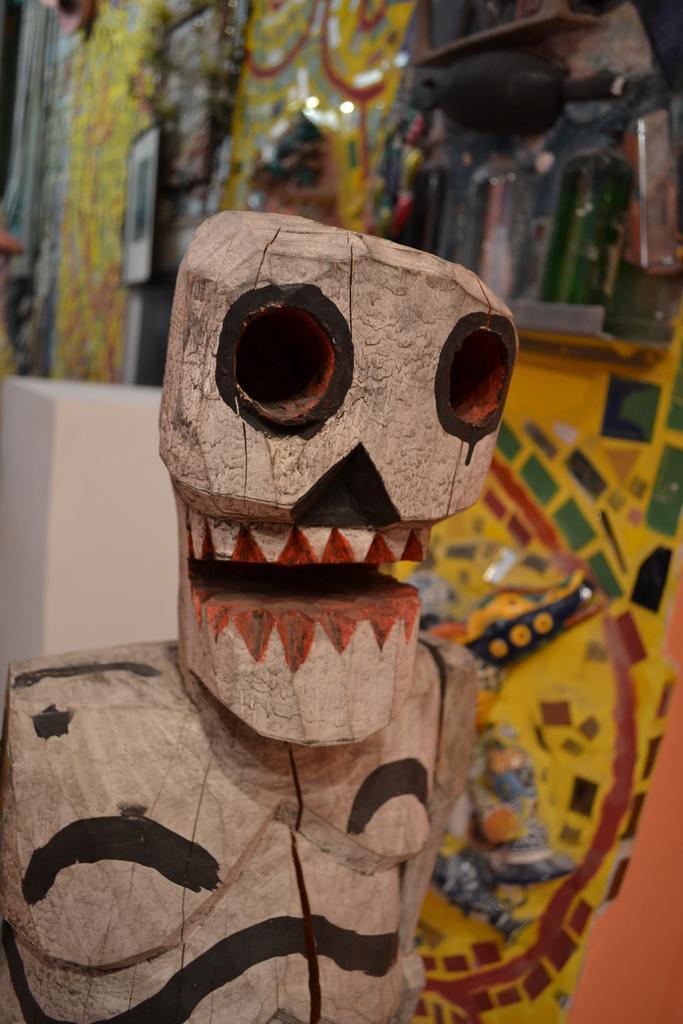In one or two sentences, can you explain what this image depicts? In the picture I can see a toy which is made of wood and there are few colors on it and there are few other objects in the background. 